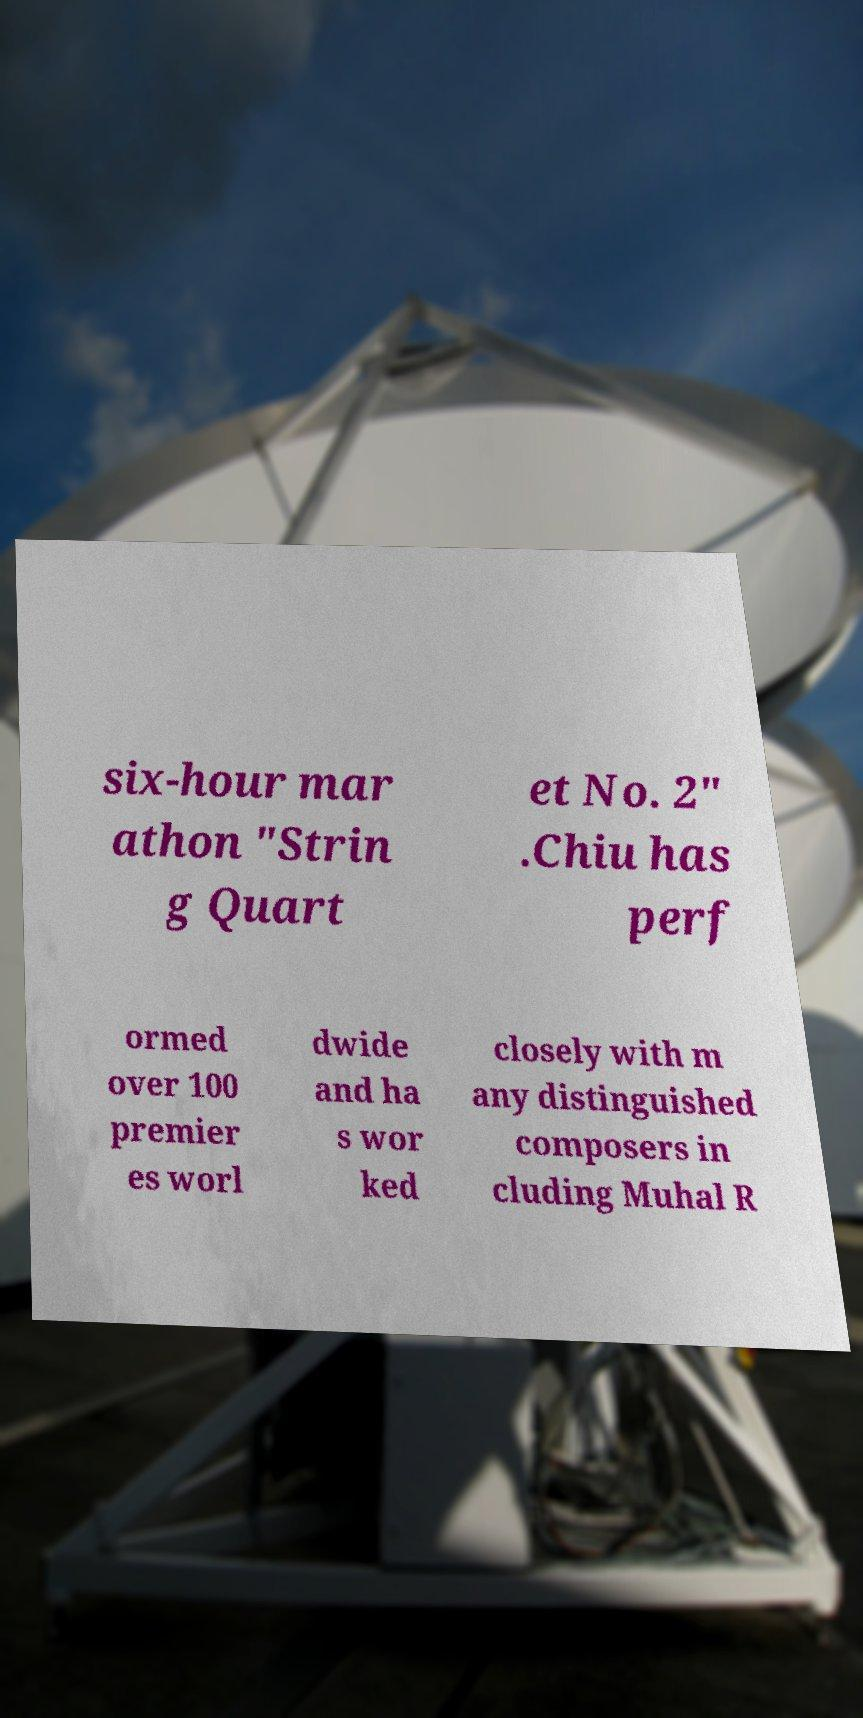There's text embedded in this image that I need extracted. Can you transcribe it verbatim? six-hour mar athon "Strin g Quart et No. 2" .Chiu has perf ormed over 100 premier es worl dwide and ha s wor ked closely with m any distinguished composers in cluding Muhal R 